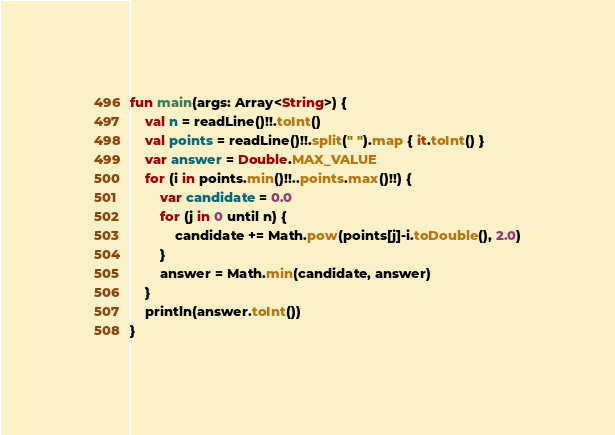<code> <loc_0><loc_0><loc_500><loc_500><_Kotlin_>fun main(args: Array<String>) {
    val n = readLine()!!.toInt()
    val points = readLine()!!.split(" ").map { it.toInt() }
    var answer = Double.MAX_VALUE
    for (i in points.min()!!..points.max()!!) {
        var candidate = 0.0
        for (j in 0 until n) {
            candidate += Math.pow(points[j]-i.toDouble(), 2.0)
        }
        answer = Math.min(candidate, answer)
    }
    println(answer.toInt())
}
</code> 